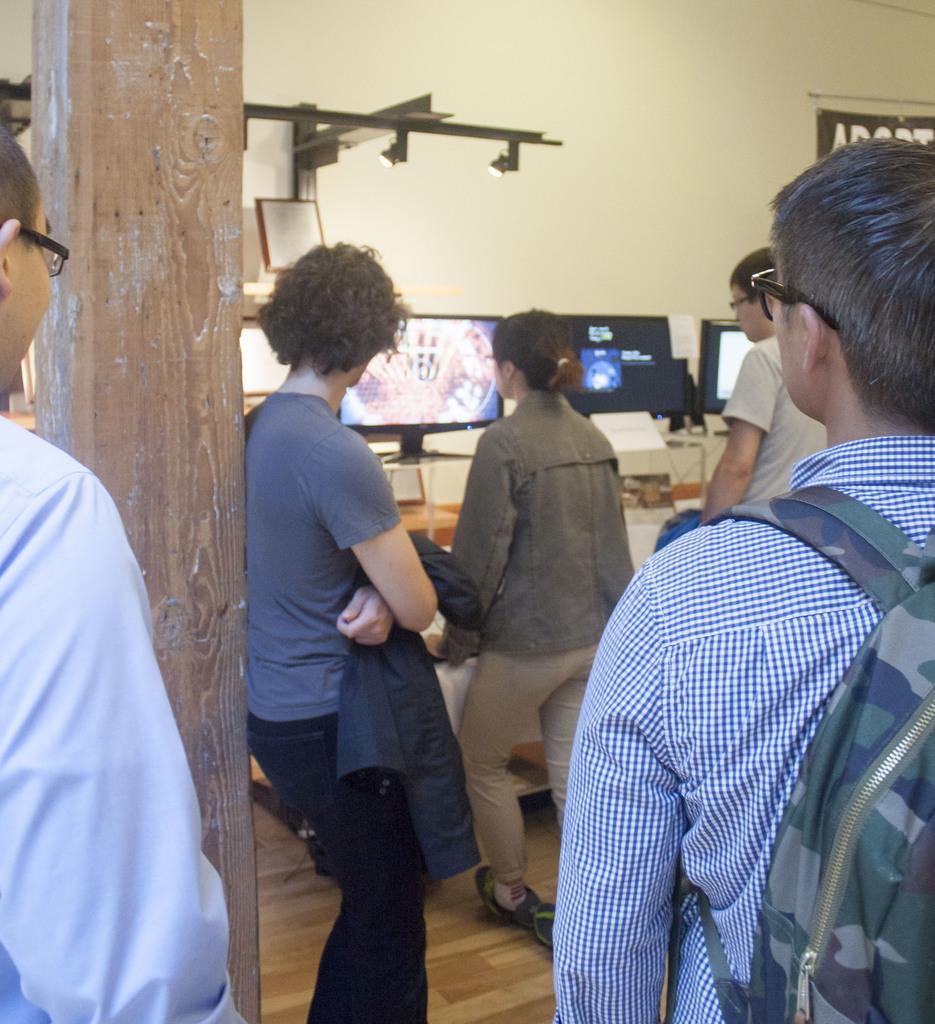Could you give a brief overview of what you see in this image? In this image we can see some group of persons standing and in the background of the image there are some monitors and there is a wall. 